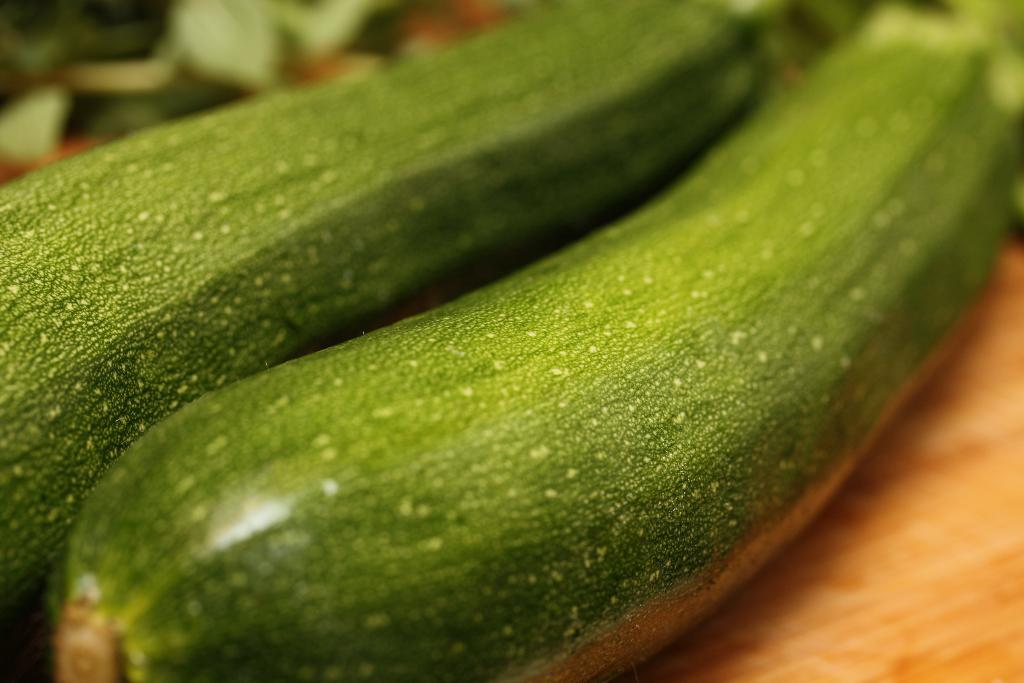What type of vegetable can be seen in the image? There are zucchinis in the image. Can you describe the quality of the image on the top and right side? The top and right side of the image have a blurred view. What can be seen in the right side bottom corner of the image? There is a surface visible in the right side bottom corner of the image. What type of music is the band playing in the image? There is no band present in the image, so it is not possible to determine what type of music they might be playing. 